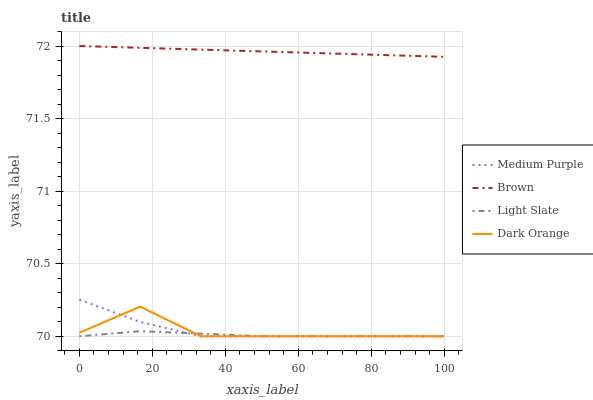Does Light Slate have the minimum area under the curve?
Answer yes or no. Yes. Does Brown have the maximum area under the curve?
Answer yes or no. Yes. Does Brown have the minimum area under the curve?
Answer yes or no. No. Does Light Slate have the maximum area under the curve?
Answer yes or no. No. Is Brown the smoothest?
Answer yes or no. Yes. Is Dark Orange the roughest?
Answer yes or no. Yes. Is Light Slate the smoothest?
Answer yes or no. No. Is Light Slate the roughest?
Answer yes or no. No. Does Medium Purple have the lowest value?
Answer yes or no. Yes. Does Brown have the lowest value?
Answer yes or no. No. Does Brown have the highest value?
Answer yes or no. Yes. Does Light Slate have the highest value?
Answer yes or no. No. Is Dark Orange less than Brown?
Answer yes or no. Yes. Is Brown greater than Medium Purple?
Answer yes or no. Yes. Does Dark Orange intersect Light Slate?
Answer yes or no. Yes. Is Dark Orange less than Light Slate?
Answer yes or no. No. Is Dark Orange greater than Light Slate?
Answer yes or no. No. Does Dark Orange intersect Brown?
Answer yes or no. No. 